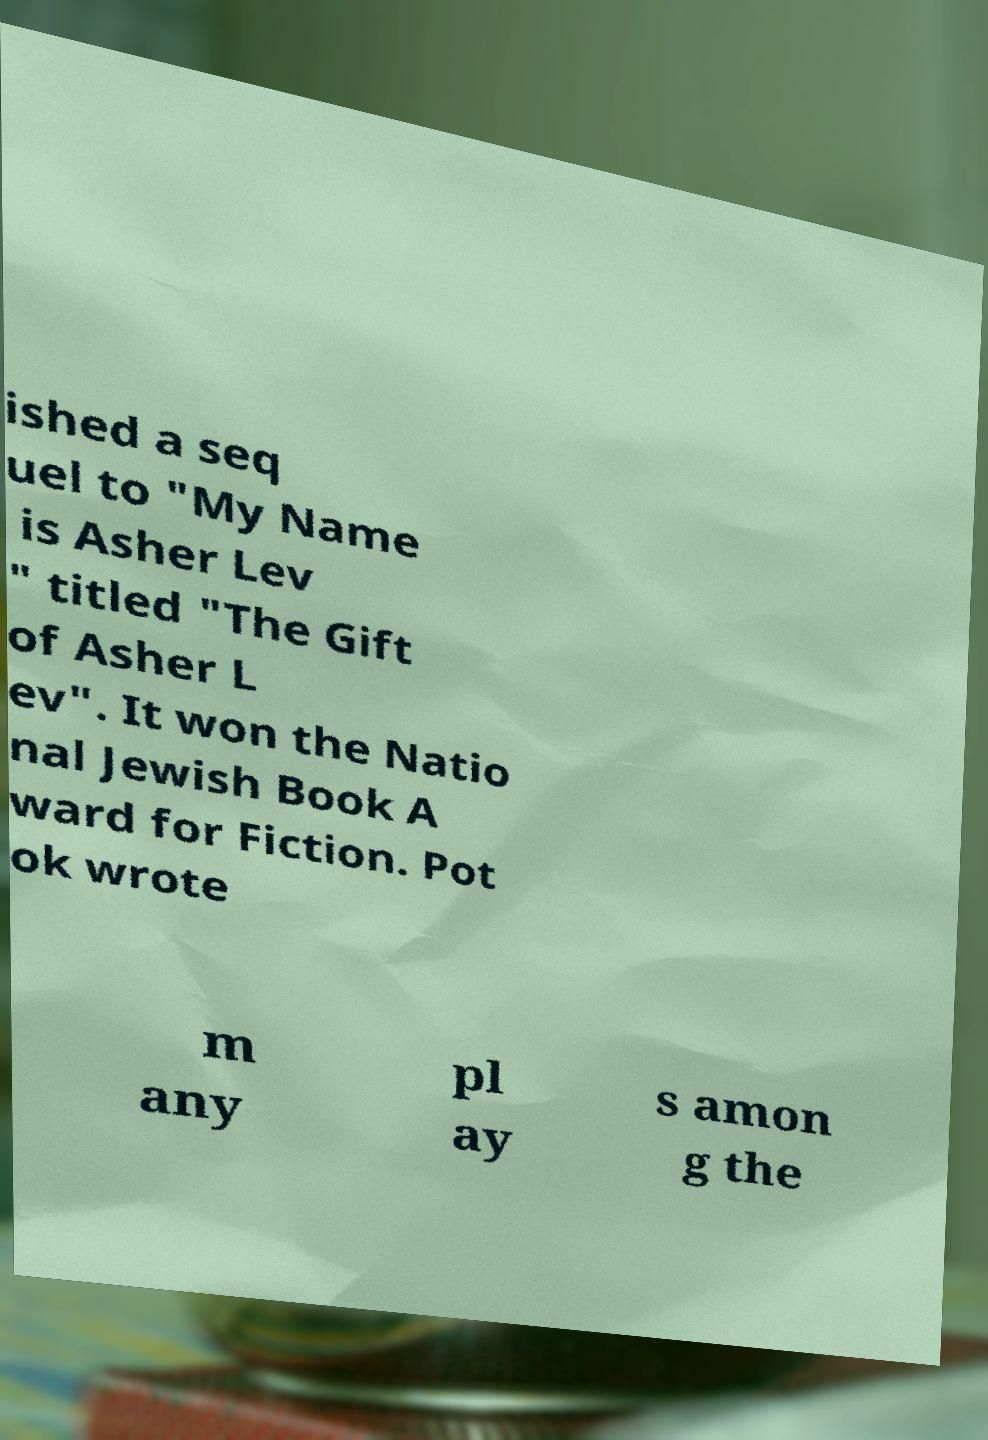Please identify and transcribe the text found in this image. ished a seq uel to "My Name is Asher Lev " titled "The Gift of Asher L ev". It won the Natio nal Jewish Book A ward for Fiction. Pot ok wrote m any pl ay s amon g the 